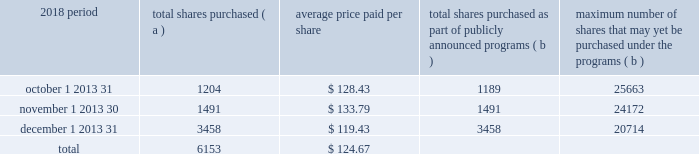The pnc financial services group , inc .
2013 form 10-k 29 part ii item 5 2013 market for registrant 2019s common equity , related stockholder matters and issuer purchases of equity securities ( a ) ( 1 ) our common stock is listed on the new york stock exchange and is traded under the symbol 201cpnc . 201d at the close of business on february 15 , 2019 , there were 53986 common shareholders of record .
Holders of pnc common stock are entitled to receive dividends when declared by our board of directors out of funds legally available for this purpose .
Our board of directors may not pay or set apart dividends on the common stock until dividends for all past dividend periods on any series of outstanding preferred stock and certain outstanding capital securities issued by the parent company have been paid or declared and set apart for payment .
The board of directors presently intends to continue the policy of paying quarterly cash dividends .
The amount of any future dividends will depend on economic and market conditions , our financial condition and operating results , and other factors , including contractual restrictions and applicable government regulations and policies ( such as those relating to the ability of bank and non-bank subsidiaries to pay dividends to the parent company and regulatory capital limitations ) .
The amount of our dividend is also currently subject to the results of the supervisory assessment of capital adequacy and capital planning processes undertaken by the federal reserve and our primary bank regulators as part of the comprehensive capital analysis and review ( ccar ) process as described in the supervision and regulation section in item 1 of this report .
The federal reserve has the power to prohibit us from paying dividends without its approval .
For further information concerning dividend restrictions and other factors that could limit our ability to pay dividends , as well as restrictions on loans , dividends or advances from bank subsidiaries to the parent company , see the supervision and regulation section in item 1 , item 1a risk factors , the liquidity and capital management portion of the risk management section in item 7 , and note 10 borrowed funds , note 15 equity and note 18 regulatory matters in the notes to consolidated financial statements in item 8 of this report , which we include here by reference .
We include here by reference the information regarding our compensation plans under which pnc equity securities are authorized for issuance as of december 31 , 2018 in the table ( with introductory paragraph and notes ) in item 12 of this report .
Our stock transfer agent and registrar is : computershare trust company , n.a .
250 royall street canton , ma 02021 800-982-7652 www.computershare.com/pnc registered shareholders may contact computershare regarding dividends and other shareholder services .
We include here by reference the information that appears under the common stock performance graph caption at the end of this item 5 .
( a ) ( 2 ) none .
( b ) not applicable .
( c ) details of our repurchases of pnc common stock during the fourth quarter of 2018 are included in the table : in thousands , except per share data 2018 period total shares purchased ( a ) average price paid per share total shares purchased as part of publicly announced programs ( b ) maximum number of shares that may yet be purchased under the programs ( b ) .
( a ) includes pnc common stock purchased in connection with our various employee benefit plans generally related to forfeitures of unvested restricted stock awards and shares used to cover employee payroll tax withholding requirements .
Note 11 employee benefit plans and note 12 stock based compensation plans in the notes to consolidated financial statements in item 8 of this report include additional information regarding our employee benefit and equity compensation plans that use pnc common stock .
( b ) on march 11 , 2015 , we announced that our board of directors approved a stock repurchase program authorization in the amount of 100 million shares of pnc common stock , effective april 1 , 2015 .
Repurchases are made in open market or privately negotiated transactions and the timing and exact amount of common stock repurchases will depend on a number of factors including , among others , market and general economic conditions , regulatory capital considerations , alternative uses of capital , the potential impact on our credit ratings , and contractual and regulatory limitations , including the results of the supervisory assessment of capital adequacy and capital planning processes undertaken by the federal reserve as part of the ccar process .
In june 2018 , we announced share repurchase programs of up to $ 2.0 billion for the four quarter period beginning with the third quarter of 2018 , including repurchases of up to $ 300 million related to stock issuances under employee benefit plans , in accordance with pnc's 2018 capital plan .
In november 2018 , we announced an increase to these previously announced programs in the amount of up to $ 900 million in additional common share repurchases .
The aggregate repurchase price of shares repurchased during the fourth quarter of 2018 was $ .8 billion .
See the liquidity and capital management portion of the risk management section in item 7 of this report for more information on the authorized share repurchase programs for the period july 1 , 2018 through june 30 , 2019 .
Http://www.computershare.com/pnc .
For the period of october 1 2013 31 , what percent of share purchases were not shares purchased as part of publicly announced programs? 
Computations: ((1204 - 1189) / 1204)
Answer: 0.01246. 